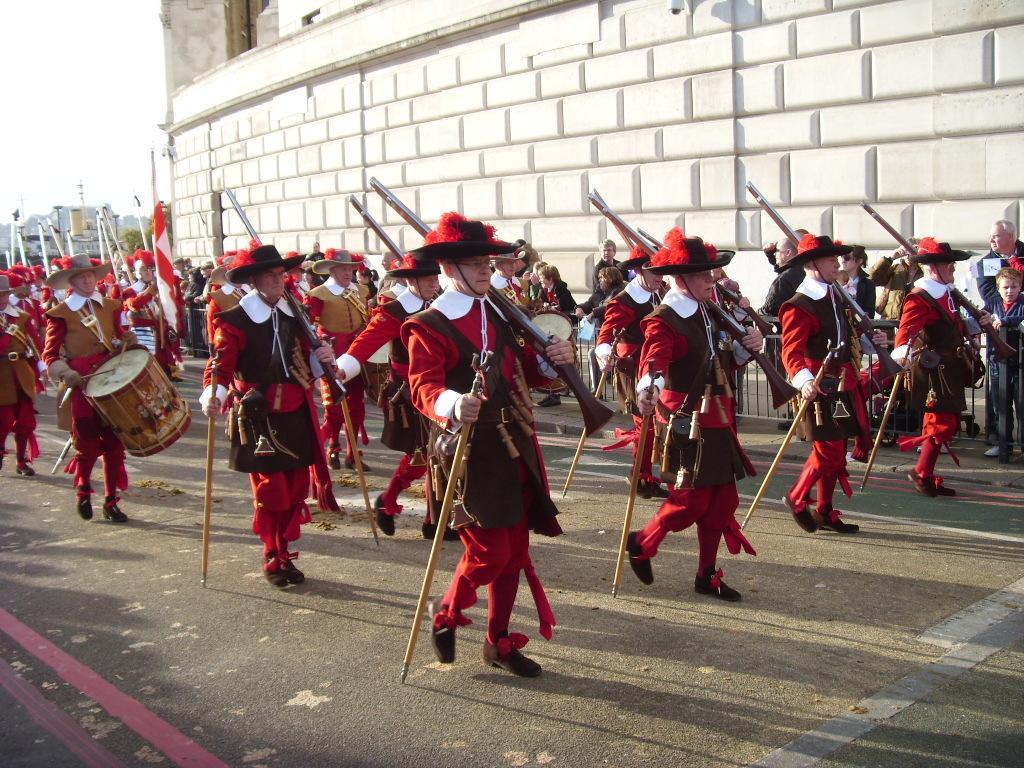Could you give a brief overview of what you see in this image? In this picture we can see a group of people walking on the road and holding sticks and guns with their hands and in the background we can see wall, buildings. 